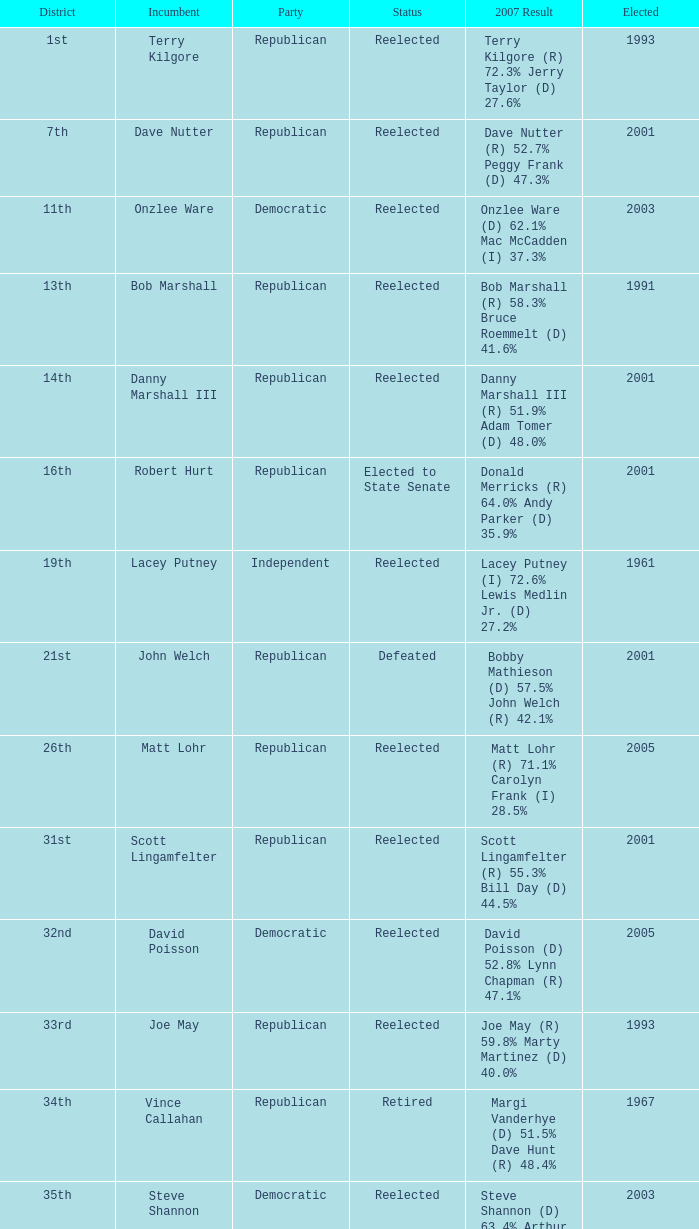What district is incument terry kilgore from? 1st. 